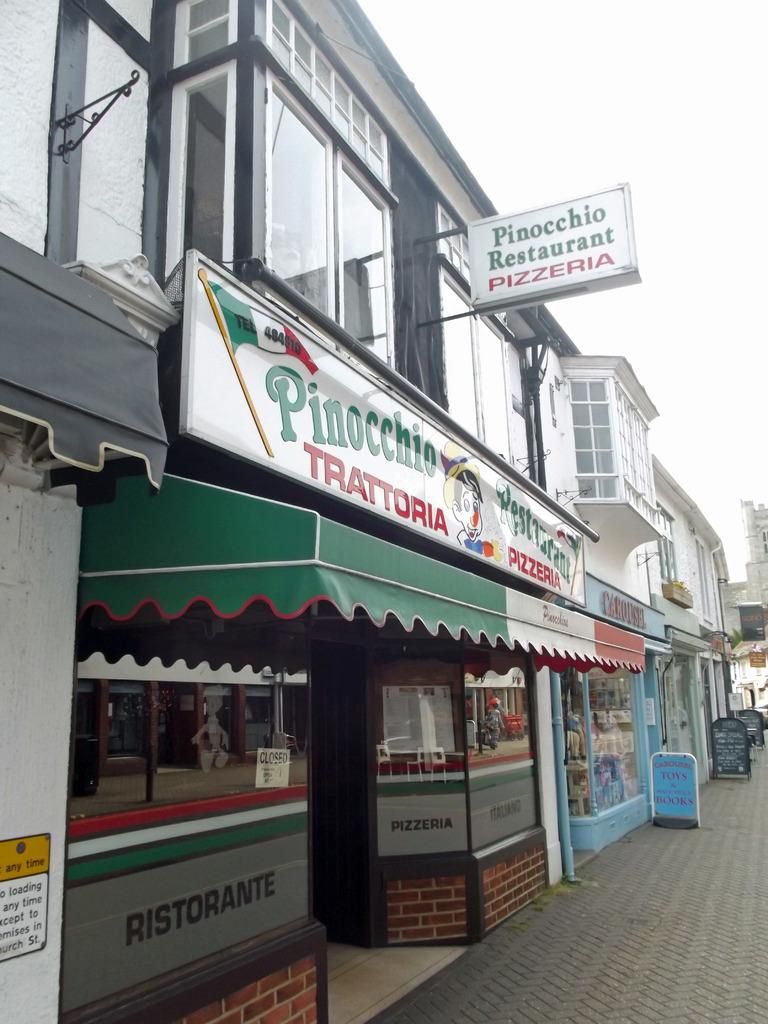Provide a one-sentence caption for the provided image. A pizza restaurant named Pinocchio Restaurant in a quiet street. 